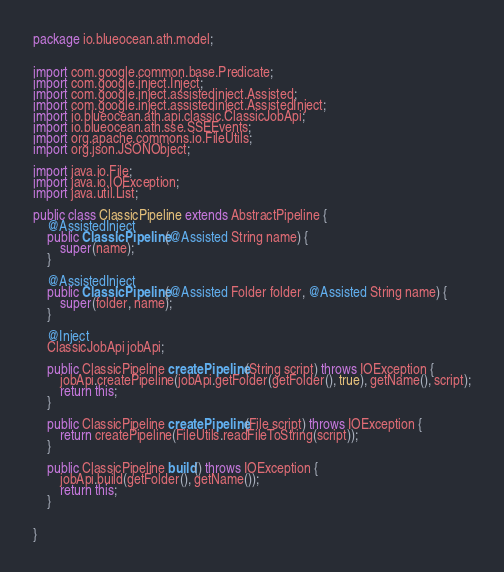Convert code to text. <code><loc_0><loc_0><loc_500><loc_500><_Java_>package io.blueocean.ath.model;


import com.google.common.base.Predicate;
import com.google.inject.Inject;
import com.google.inject.assistedinject.Assisted;
import com.google.inject.assistedinject.AssistedInject;
import io.blueocean.ath.api.classic.ClassicJobApi;
import io.blueocean.ath.sse.SSEEvents;
import org.apache.commons.io.FileUtils;
import org.json.JSONObject;

import java.io.File;
import java.io.IOException;
import java.util.List;

public class ClassicPipeline extends AbstractPipeline {
    @AssistedInject
    public ClassicPipeline(@Assisted String name) {
        super(name);
    }

    @AssistedInject
    public ClassicPipeline(@Assisted Folder folder, @Assisted String name) {
        super(folder, name);
    }

    @Inject
    ClassicJobApi jobApi;

    public ClassicPipeline createPipeline(String script) throws IOException {
        jobApi.createPipeline(jobApi.getFolder(getFolder(), true), getName(), script);
        return this;
    }

    public ClassicPipeline createPipeline(File script) throws IOException {
        return createPipeline(FileUtils.readFileToString(script));
    }

    public ClassicPipeline build() throws IOException {
        jobApi.build(getFolder(), getName());
        return this;
    }


}
</code> 